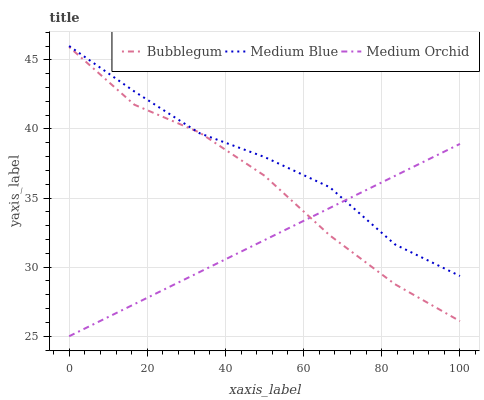Does Medium Orchid have the minimum area under the curve?
Answer yes or no. Yes. Does Medium Blue have the maximum area under the curve?
Answer yes or no. Yes. Does Bubblegum have the minimum area under the curve?
Answer yes or no. No. Does Bubblegum have the maximum area under the curve?
Answer yes or no. No. Is Medium Orchid the smoothest?
Answer yes or no. Yes. Is Bubblegum the roughest?
Answer yes or no. Yes. Is Medium Blue the smoothest?
Answer yes or no. No. Is Medium Blue the roughest?
Answer yes or no. No. Does Bubblegum have the lowest value?
Answer yes or no. No. Does Medium Blue have the highest value?
Answer yes or no. Yes. Does Bubblegum have the highest value?
Answer yes or no. No. Does Medium Orchid intersect Medium Blue?
Answer yes or no. Yes. Is Medium Orchid less than Medium Blue?
Answer yes or no. No. Is Medium Orchid greater than Medium Blue?
Answer yes or no. No. 